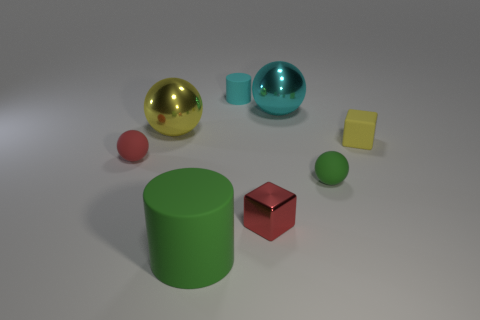What color is the object that is both right of the cyan matte cylinder and behind the large yellow shiny ball?
Give a very brief answer. Cyan. The small metal block has what color?
Your answer should be very brief. Red. Does the small yellow cube have the same material as the green object that is right of the tiny cyan rubber cylinder?
Offer a terse response. Yes. The small cyan object that is the same material as the small yellow block is what shape?
Your answer should be very brief. Cylinder. What is the color of the rubber object that is the same size as the cyan metallic ball?
Provide a short and direct response. Green. Do the matte cylinder that is behind the yellow matte thing and the big yellow ball have the same size?
Ensure brevity in your answer.  No. Is the color of the shiny cube the same as the matte cube?
Offer a very short reply. No. What number of tiny red spheres are there?
Make the answer very short. 1. What number of cylinders are either large green objects or green things?
Your answer should be compact. 1. What number of small matte things are to the left of the big metallic object to the right of the big rubber cylinder?
Your answer should be compact. 2. 